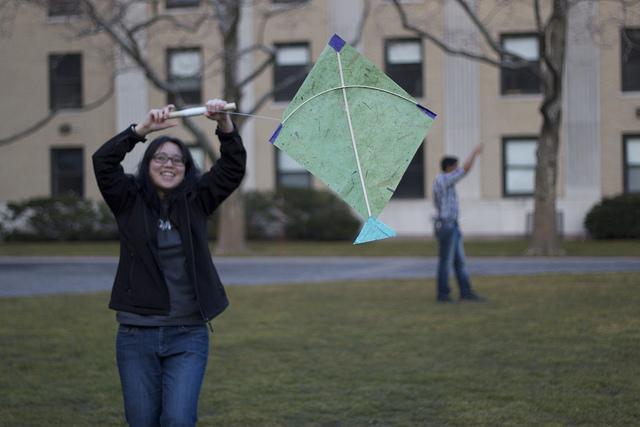How many chimneys are visible?
Give a very brief answer. 0. How many windows?
Give a very brief answer. 12. How many people are in the photo?
Give a very brief answer. 2. How many beds are in this room?
Give a very brief answer. 0. 